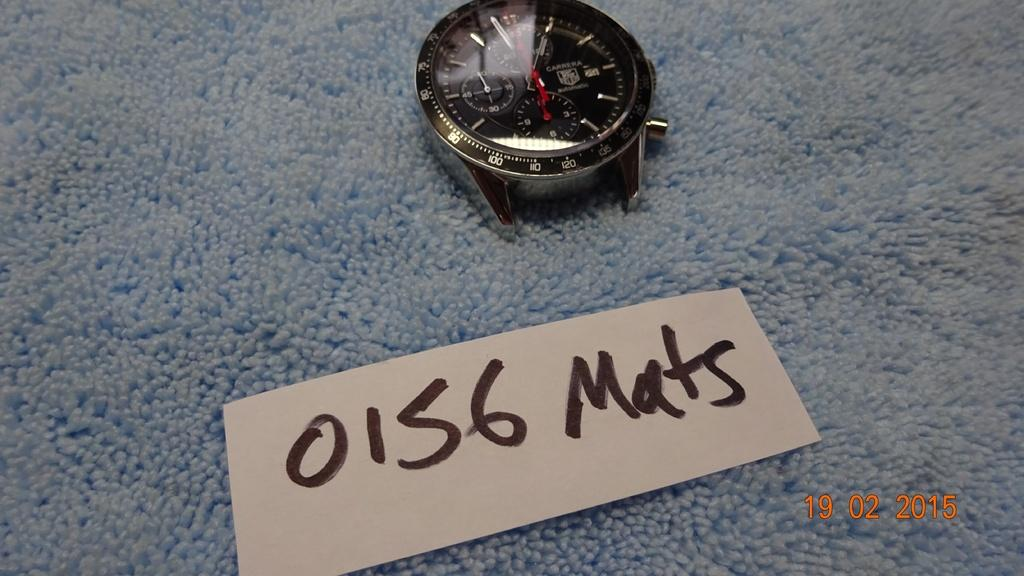Provide a one-sentence caption for the provided image. A watch is set on a blue plush surface with the marker 0156 Mats by it. 